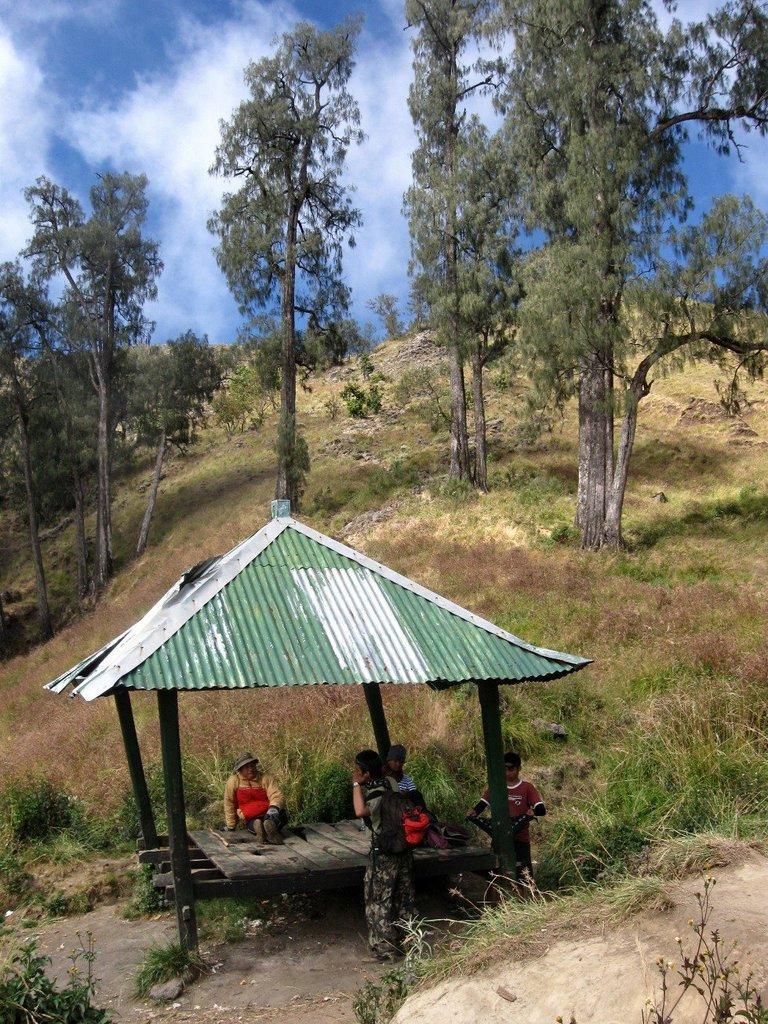Describe this image in one or two sentences. In this picture, it looks like a pergola. In the pergola, there is a group of people. Behind the pergola there are trees, grass and the sky. 